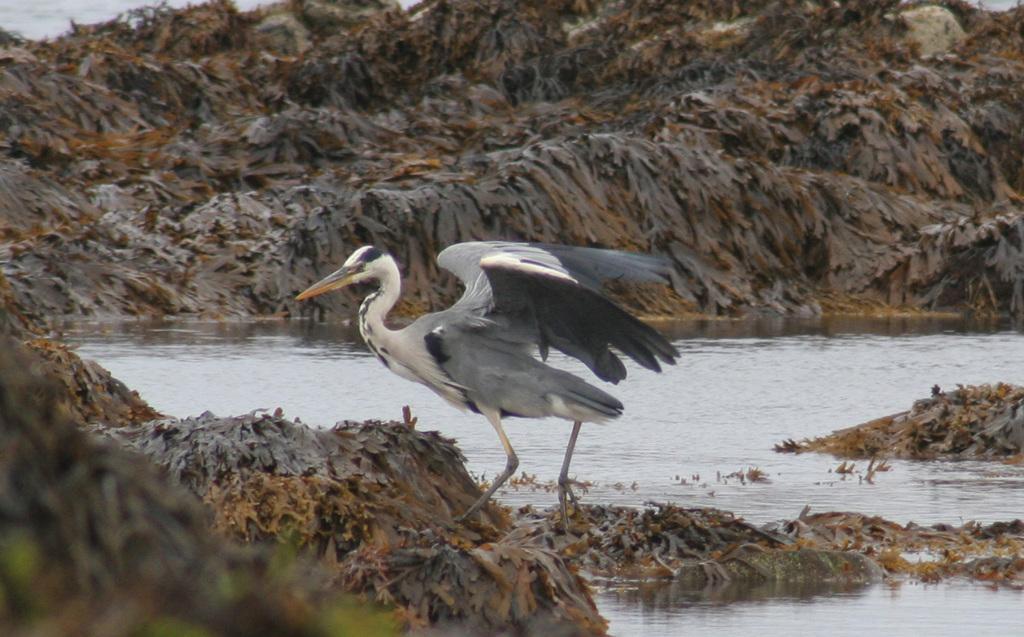Describe this image in one or two sentences. This picture shows a crane and we see water and the crane is white and black in color. 